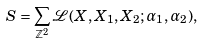Convert formula to latex. <formula><loc_0><loc_0><loc_500><loc_500>S = \sum _ { \mathbb { Z } ^ { 2 } } \mathcal { L } ( X , X _ { 1 } , X _ { 2 } ; \alpha _ { 1 } , \alpha _ { 2 } ) ,</formula> 